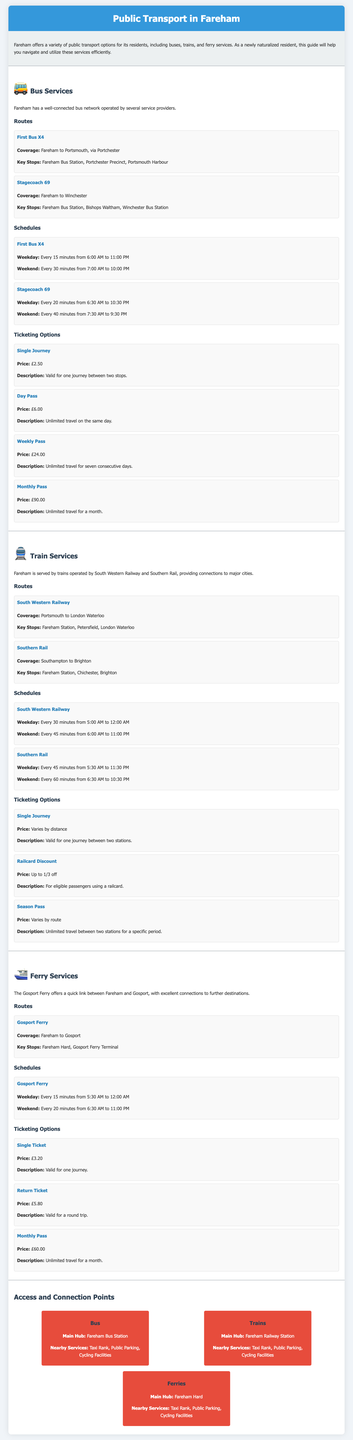What is the coverage of the First Bus X4? The First Bus X4 covers Fareham to Portsmouth, via Portchester.
Answer: Fareham to Portsmouth, via Portchester How often does the Stagecoach 69 bus run on weekdays? The schedule states that the Stagecoach 69 bus runs every 20 minutes on weekdays.
Answer: Every 20 minutes What is the price of a single ticket for the Gosport Ferry? The document indicates that the price of a single ticket for the Gosport Ferry is £3.20.
Answer: £3.20 What is the main hub for train services in Fareham? The main hub for train services is mentioned as Fareham Railway Station.
Answer: Fareham Railway Station How many minutes apart do ferries run on weekends? The schedule indicates ferries run every 20 minutes on weekends.
Answer: Every 20 minutes What is the price of the Weekly Pass for bus services? The document states that the price of the Weekly Pass is £24.00.
Answer: £24.00 Which bus route connects Fareham to Winchester? The Stagecoach 69 connects Fareham to Winchester.
Answer: Stagecoach 69 What is the duration of a monthly pass for the Gosport Ferry? The monthly pass for the Gosport Ferry provides unlimited travel for a month.
Answer: A month 